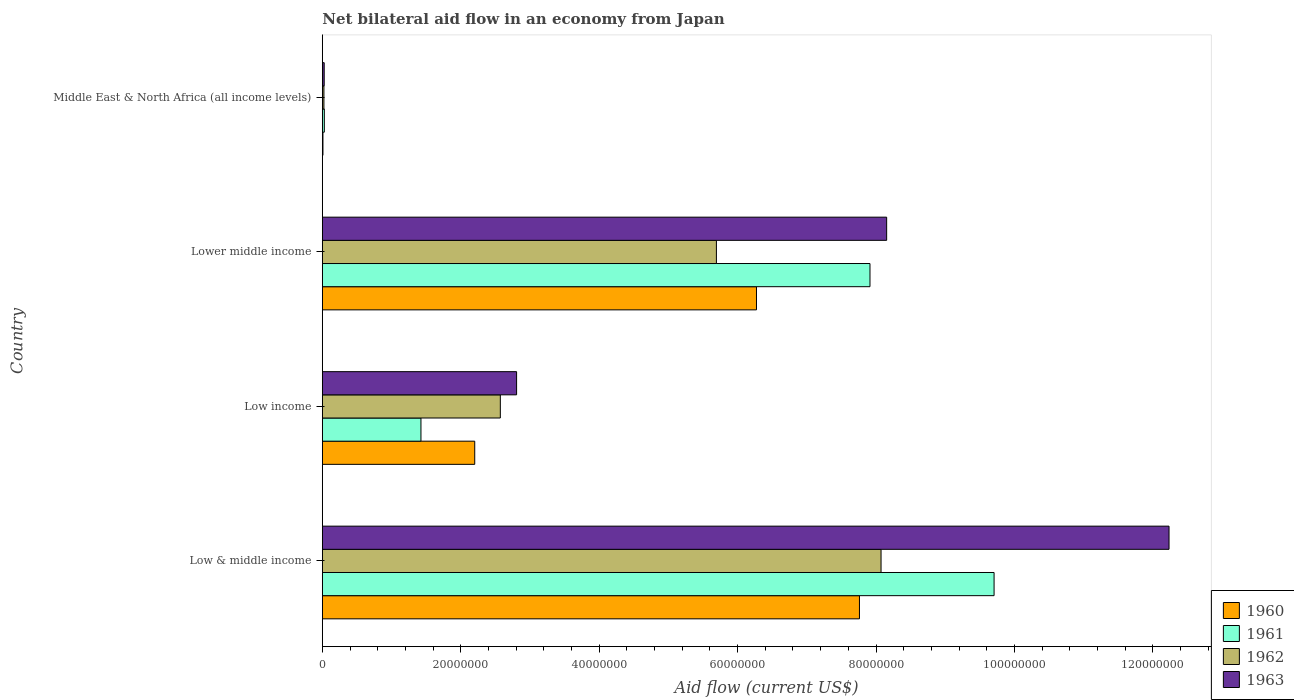How many groups of bars are there?
Provide a succinct answer. 4. Are the number of bars per tick equal to the number of legend labels?
Offer a very short reply. Yes. How many bars are there on the 1st tick from the bottom?
Give a very brief answer. 4. What is the label of the 4th group of bars from the top?
Make the answer very short. Low & middle income. In how many cases, is the number of bars for a given country not equal to the number of legend labels?
Offer a terse response. 0. What is the net bilateral aid flow in 1961 in Low & middle income?
Your answer should be very brief. 9.71e+07. Across all countries, what is the maximum net bilateral aid flow in 1961?
Your answer should be very brief. 9.71e+07. Across all countries, what is the minimum net bilateral aid flow in 1963?
Give a very brief answer. 2.70e+05. In which country was the net bilateral aid flow in 1962 maximum?
Offer a terse response. Low & middle income. In which country was the net bilateral aid flow in 1960 minimum?
Your answer should be compact. Middle East & North Africa (all income levels). What is the total net bilateral aid flow in 1961 in the graph?
Ensure brevity in your answer.  1.91e+08. What is the difference between the net bilateral aid flow in 1963 in Low income and that in Middle East & North Africa (all income levels)?
Offer a very short reply. 2.78e+07. What is the difference between the net bilateral aid flow in 1960 in Lower middle income and the net bilateral aid flow in 1963 in Low income?
Give a very brief answer. 3.47e+07. What is the average net bilateral aid flow in 1963 per country?
Keep it short and to the point. 5.81e+07. What is the difference between the net bilateral aid flow in 1963 and net bilateral aid flow in 1960 in Low income?
Offer a terse response. 6.05e+06. In how many countries, is the net bilateral aid flow in 1963 greater than 68000000 US$?
Provide a succinct answer. 2. What is the ratio of the net bilateral aid flow in 1963 in Low & middle income to that in Middle East & North Africa (all income levels)?
Give a very brief answer. 453.11. Is the net bilateral aid flow in 1963 in Low & middle income less than that in Low income?
Keep it short and to the point. No. Is the difference between the net bilateral aid flow in 1963 in Low & middle income and Middle East & North Africa (all income levels) greater than the difference between the net bilateral aid flow in 1960 in Low & middle income and Middle East & North Africa (all income levels)?
Offer a very short reply. Yes. What is the difference between the highest and the second highest net bilateral aid flow in 1962?
Your answer should be compact. 2.38e+07. What is the difference between the highest and the lowest net bilateral aid flow in 1962?
Offer a terse response. 8.05e+07. In how many countries, is the net bilateral aid flow in 1960 greater than the average net bilateral aid flow in 1960 taken over all countries?
Offer a terse response. 2. Is the sum of the net bilateral aid flow in 1960 in Low income and Lower middle income greater than the maximum net bilateral aid flow in 1962 across all countries?
Make the answer very short. Yes. What does the 3rd bar from the bottom in Low & middle income represents?
Offer a very short reply. 1962. Is it the case that in every country, the sum of the net bilateral aid flow in 1963 and net bilateral aid flow in 1960 is greater than the net bilateral aid flow in 1961?
Offer a terse response. Yes. Are all the bars in the graph horizontal?
Your answer should be very brief. Yes. How many countries are there in the graph?
Offer a very short reply. 4. Does the graph contain any zero values?
Keep it short and to the point. No. Does the graph contain grids?
Make the answer very short. No. Where does the legend appear in the graph?
Give a very brief answer. Bottom right. How many legend labels are there?
Your answer should be very brief. 4. How are the legend labels stacked?
Offer a terse response. Vertical. What is the title of the graph?
Your answer should be compact. Net bilateral aid flow in an economy from Japan. What is the label or title of the X-axis?
Make the answer very short. Aid flow (current US$). What is the label or title of the Y-axis?
Provide a short and direct response. Country. What is the Aid flow (current US$) in 1960 in Low & middle income?
Offer a very short reply. 7.76e+07. What is the Aid flow (current US$) of 1961 in Low & middle income?
Offer a terse response. 9.71e+07. What is the Aid flow (current US$) of 1962 in Low & middle income?
Provide a short and direct response. 8.07e+07. What is the Aid flow (current US$) of 1963 in Low & middle income?
Offer a very short reply. 1.22e+08. What is the Aid flow (current US$) in 1960 in Low income?
Provide a short and direct response. 2.20e+07. What is the Aid flow (current US$) in 1961 in Low income?
Give a very brief answer. 1.42e+07. What is the Aid flow (current US$) in 1962 in Low income?
Your answer should be compact. 2.57e+07. What is the Aid flow (current US$) in 1963 in Low income?
Ensure brevity in your answer.  2.81e+07. What is the Aid flow (current US$) of 1960 in Lower middle income?
Make the answer very short. 6.27e+07. What is the Aid flow (current US$) of 1961 in Lower middle income?
Your response must be concise. 7.91e+07. What is the Aid flow (current US$) in 1962 in Lower middle income?
Offer a terse response. 5.69e+07. What is the Aid flow (current US$) of 1963 in Lower middle income?
Provide a short and direct response. 8.15e+07. What is the Aid flow (current US$) in 1960 in Middle East & North Africa (all income levels)?
Offer a terse response. 9.00e+04. What is the Aid flow (current US$) in 1962 in Middle East & North Africa (all income levels)?
Your answer should be very brief. 2.30e+05. What is the Aid flow (current US$) of 1963 in Middle East & North Africa (all income levels)?
Provide a succinct answer. 2.70e+05. Across all countries, what is the maximum Aid flow (current US$) of 1960?
Offer a terse response. 7.76e+07. Across all countries, what is the maximum Aid flow (current US$) in 1961?
Your answer should be very brief. 9.71e+07. Across all countries, what is the maximum Aid flow (current US$) of 1962?
Give a very brief answer. 8.07e+07. Across all countries, what is the maximum Aid flow (current US$) in 1963?
Give a very brief answer. 1.22e+08. Across all countries, what is the minimum Aid flow (current US$) of 1961?
Keep it short and to the point. 2.90e+05. Across all countries, what is the minimum Aid flow (current US$) in 1963?
Your answer should be compact. 2.70e+05. What is the total Aid flow (current US$) of 1960 in the graph?
Offer a terse response. 1.62e+08. What is the total Aid flow (current US$) of 1961 in the graph?
Give a very brief answer. 1.91e+08. What is the total Aid flow (current US$) in 1962 in the graph?
Keep it short and to the point. 1.64e+08. What is the total Aid flow (current US$) of 1963 in the graph?
Ensure brevity in your answer.  2.32e+08. What is the difference between the Aid flow (current US$) in 1960 in Low & middle income and that in Low income?
Your answer should be very brief. 5.56e+07. What is the difference between the Aid flow (current US$) in 1961 in Low & middle income and that in Low income?
Provide a short and direct response. 8.28e+07. What is the difference between the Aid flow (current US$) of 1962 in Low & middle income and that in Low income?
Provide a succinct answer. 5.50e+07. What is the difference between the Aid flow (current US$) of 1963 in Low & middle income and that in Low income?
Offer a very short reply. 9.43e+07. What is the difference between the Aid flow (current US$) in 1960 in Low & middle income and that in Lower middle income?
Your answer should be very brief. 1.49e+07. What is the difference between the Aid flow (current US$) in 1961 in Low & middle income and that in Lower middle income?
Provide a succinct answer. 1.79e+07. What is the difference between the Aid flow (current US$) of 1962 in Low & middle income and that in Lower middle income?
Offer a terse response. 2.38e+07. What is the difference between the Aid flow (current US$) of 1963 in Low & middle income and that in Lower middle income?
Offer a very short reply. 4.08e+07. What is the difference between the Aid flow (current US$) of 1960 in Low & middle income and that in Middle East & North Africa (all income levels)?
Your response must be concise. 7.75e+07. What is the difference between the Aid flow (current US$) of 1961 in Low & middle income and that in Middle East & North Africa (all income levels)?
Your answer should be compact. 9.68e+07. What is the difference between the Aid flow (current US$) of 1962 in Low & middle income and that in Middle East & North Africa (all income levels)?
Give a very brief answer. 8.05e+07. What is the difference between the Aid flow (current US$) of 1963 in Low & middle income and that in Middle East & North Africa (all income levels)?
Offer a very short reply. 1.22e+08. What is the difference between the Aid flow (current US$) in 1960 in Low income and that in Lower middle income?
Your answer should be compact. -4.07e+07. What is the difference between the Aid flow (current US$) of 1961 in Low income and that in Lower middle income?
Your answer should be compact. -6.49e+07. What is the difference between the Aid flow (current US$) in 1962 in Low income and that in Lower middle income?
Offer a terse response. -3.12e+07. What is the difference between the Aid flow (current US$) of 1963 in Low income and that in Lower middle income?
Keep it short and to the point. -5.35e+07. What is the difference between the Aid flow (current US$) in 1960 in Low income and that in Middle East & North Africa (all income levels)?
Offer a very short reply. 2.19e+07. What is the difference between the Aid flow (current US$) in 1961 in Low income and that in Middle East & North Africa (all income levels)?
Offer a very short reply. 1.40e+07. What is the difference between the Aid flow (current US$) in 1962 in Low income and that in Middle East & North Africa (all income levels)?
Give a very brief answer. 2.55e+07. What is the difference between the Aid flow (current US$) in 1963 in Low income and that in Middle East & North Africa (all income levels)?
Make the answer very short. 2.78e+07. What is the difference between the Aid flow (current US$) of 1960 in Lower middle income and that in Middle East & North Africa (all income levels)?
Ensure brevity in your answer.  6.26e+07. What is the difference between the Aid flow (current US$) of 1961 in Lower middle income and that in Middle East & North Africa (all income levels)?
Offer a terse response. 7.88e+07. What is the difference between the Aid flow (current US$) of 1962 in Lower middle income and that in Middle East & North Africa (all income levels)?
Provide a short and direct response. 5.67e+07. What is the difference between the Aid flow (current US$) in 1963 in Lower middle income and that in Middle East & North Africa (all income levels)?
Your response must be concise. 8.13e+07. What is the difference between the Aid flow (current US$) in 1960 in Low & middle income and the Aid flow (current US$) in 1961 in Low income?
Offer a very short reply. 6.34e+07. What is the difference between the Aid flow (current US$) in 1960 in Low & middle income and the Aid flow (current US$) in 1962 in Low income?
Keep it short and to the point. 5.19e+07. What is the difference between the Aid flow (current US$) of 1960 in Low & middle income and the Aid flow (current US$) of 1963 in Low income?
Provide a succinct answer. 4.95e+07. What is the difference between the Aid flow (current US$) in 1961 in Low & middle income and the Aid flow (current US$) in 1962 in Low income?
Give a very brief answer. 7.13e+07. What is the difference between the Aid flow (current US$) of 1961 in Low & middle income and the Aid flow (current US$) of 1963 in Low income?
Give a very brief answer. 6.90e+07. What is the difference between the Aid flow (current US$) of 1962 in Low & middle income and the Aid flow (current US$) of 1963 in Low income?
Keep it short and to the point. 5.27e+07. What is the difference between the Aid flow (current US$) in 1960 in Low & middle income and the Aid flow (current US$) in 1961 in Lower middle income?
Your answer should be very brief. -1.52e+06. What is the difference between the Aid flow (current US$) of 1960 in Low & middle income and the Aid flow (current US$) of 1962 in Lower middle income?
Your answer should be very brief. 2.07e+07. What is the difference between the Aid flow (current US$) in 1960 in Low & middle income and the Aid flow (current US$) in 1963 in Lower middle income?
Your response must be concise. -3.93e+06. What is the difference between the Aid flow (current US$) of 1961 in Low & middle income and the Aid flow (current US$) of 1962 in Lower middle income?
Offer a very short reply. 4.01e+07. What is the difference between the Aid flow (current US$) of 1961 in Low & middle income and the Aid flow (current US$) of 1963 in Lower middle income?
Provide a succinct answer. 1.55e+07. What is the difference between the Aid flow (current US$) in 1962 in Low & middle income and the Aid flow (current US$) in 1963 in Lower middle income?
Offer a very short reply. -8.10e+05. What is the difference between the Aid flow (current US$) in 1960 in Low & middle income and the Aid flow (current US$) in 1961 in Middle East & North Africa (all income levels)?
Keep it short and to the point. 7.73e+07. What is the difference between the Aid flow (current US$) in 1960 in Low & middle income and the Aid flow (current US$) in 1962 in Middle East & North Africa (all income levels)?
Give a very brief answer. 7.74e+07. What is the difference between the Aid flow (current US$) of 1960 in Low & middle income and the Aid flow (current US$) of 1963 in Middle East & North Africa (all income levels)?
Your response must be concise. 7.73e+07. What is the difference between the Aid flow (current US$) in 1961 in Low & middle income and the Aid flow (current US$) in 1962 in Middle East & North Africa (all income levels)?
Make the answer very short. 9.68e+07. What is the difference between the Aid flow (current US$) in 1961 in Low & middle income and the Aid flow (current US$) in 1963 in Middle East & North Africa (all income levels)?
Your answer should be compact. 9.68e+07. What is the difference between the Aid flow (current US$) of 1962 in Low & middle income and the Aid flow (current US$) of 1963 in Middle East & North Africa (all income levels)?
Provide a succinct answer. 8.05e+07. What is the difference between the Aid flow (current US$) in 1960 in Low income and the Aid flow (current US$) in 1961 in Lower middle income?
Your response must be concise. -5.71e+07. What is the difference between the Aid flow (current US$) of 1960 in Low income and the Aid flow (current US$) of 1962 in Lower middle income?
Your response must be concise. -3.49e+07. What is the difference between the Aid flow (current US$) of 1960 in Low income and the Aid flow (current US$) of 1963 in Lower middle income?
Provide a short and direct response. -5.95e+07. What is the difference between the Aid flow (current US$) of 1961 in Low income and the Aid flow (current US$) of 1962 in Lower middle income?
Your response must be concise. -4.27e+07. What is the difference between the Aid flow (current US$) of 1961 in Low income and the Aid flow (current US$) of 1963 in Lower middle income?
Your answer should be very brief. -6.73e+07. What is the difference between the Aid flow (current US$) in 1962 in Low income and the Aid flow (current US$) in 1963 in Lower middle income?
Give a very brief answer. -5.58e+07. What is the difference between the Aid flow (current US$) in 1960 in Low income and the Aid flow (current US$) in 1961 in Middle East & North Africa (all income levels)?
Give a very brief answer. 2.17e+07. What is the difference between the Aid flow (current US$) of 1960 in Low income and the Aid flow (current US$) of 1962 in Middle East & North Africa (all income levels)?
Ensure brevity in your answer.  2.18e+07. What is the difference between the Aid flow (current US$) in 1960 in Low income and the Aid flow (current US$) in 1963 in Middle East & North Africa (all income levels)?
Keep it short and to the point. 2.18e+07. What is the difference between the Aid flow (current US$) of 1961 in Low income and the Aid flow (current US$) of 1962 in Middle East & North Africa (all income levels)?
Keep it short and to the point. 1.40e+07. What is the difference between the Aid flow (current US$) of 1961 in Low income and the Aid flow (current US$) of 1963 in Middle East & North Africa (all income levels)?
Your response must be concise. 1.40e+07. What is the difference between the Aid flow (current US$) in 1962 in Low income and the Aid flow (current US$) in 1963 in Middle East & North Africa (all income levels)?
Provide a succinct answer. 2.54e+07. What is the difference between the Aid flow (current US$) in 1960 in Lower middle income and the Aid flow (current US$) in 1961 in Middle East & North Africa (all income levels)?
Your response must be concise. 6.24e+07. What is the difference between the Aid flow (current US$) in 1960 in Lower middle income and the Aid flow (current US$) in 1962 in Middle East & North Africa (all income levels)?
Your response must be concise. 6.25e+07. What is the difference between the Aid flow (current US$) in 1960 in Lower middle income and the Aid flow (current US$) in 1963 in Middle East & North Africa (all income levels)?
Give a very brief answer. 6.25e+07. What is the difference between the Aid flow (current US$) of 1961 in Lower middle income and the Aid flow (current US$) of 1962 in Middle East & North Africa (all income levels)?
Offer a very short reply. 7.89e+07. What is the difference between the Aid flow (current US$) in 1961 in Lower middle income and the Aid flow (current US$) in 1963 in Middle East & North Africa (all income levels)?
Offer a very short reply. 7.89e+07. What is the difference between the Aid flow (current US$) in 1962 in Lower middle income and the Aid flow (current US$) in 1963 in Middle East & North Africa (all income levels)?
Ensure brevity in your answer.  5.67e+07. What is the average Aid flow (current US$) of 1960 per country?
Give a very brief answer. 4.06e+07. What is the average Aid flow (current US$) of 1961 per country?
Offer a very short reply. 4.77e+07. What is the average Aid flow (current US$) in 1962 per country?
Your answer should be very brief. 4.09e+07. What is the average Aid flow (current US$) of 1963 per country?
Offer a very short reply. 5.81e+07. What is the difference between the Aid flow (current US$) of 1960 and Aid flow (current US$) of 1961 in Low & middle income?
Your answer should be compact. -1.94e+07. What is the difference between the Aid flow (current US$) in 1960 and Aid flow (current US$) in 1962 in Low & middle income?
Keep it short and to the point. -3.12e+06. What is the difference between the Aid flow (current US$) in 1960 and Aid flow (current US$) in 1963 in Low & middle income?
Your answer should be very brief. -4.47e+07. What is the difference between the Aid flow (current US$) of 1961 and Aid flow (current US$) of 1962 in Low & middle income?
Your answer should be compact. 1.63e+07. What is the difference between the Aid flow (current US$) of 1961 and Aid flow (current US$) of 1963 in Low & middle income?
Offer a very short reply. -2.53e+07. What is the difference between the Aid flow (current US$) of 1962 and Aid flow (current US$) of 1963 in Low & middle income?
Make the answer very short. -4.16e+07. What is the difference between the Aid flow (current US$) in 1960 and Aid flow (current US$) in 1961 in Low income?
Offer a terse response. 7.77e+06. What is the difference between the Aid flow (current US$) in 1960 and Aid flow (current US$) in 1962 in Low income?
Give a very brief answer. -3.70e+06. What is the difference between the Aid flow (current US$) of 1960 and Aid flow (current US$) of 1963 in Low income?
Your answer should be compact. -6.05e+06. What is the difference between the Aid flow (current US$) of 1961 and Aid flow (current US$) of 1962 in Low income?
Provide a short and direct response. -1.15e+07. What is the difference between the Aid flow (current US$) of 1961 and Aid flow (current US$) of 1963 in Low income?
Ensure brevity in your answer.  -1.38e+07. What is the difference between the Aid flow (current US$) of 1962 and Aid flow (current US$) of 1963 in Low income?
Ensure brevity in your answer.  -2.35e+06. What is the difference between the Aid flow (current US$) in 1960 and Aid flow (current US$) in 1961 in Lower middle income?
Offer a very short reply. -1.64e+07. What is the difference between the Aid flow (current US$) in 1960 and Aid flow (current US$) in 1962 in Lower middle income?
Offer a very short reply. 5.79e+06. What is the difference between the Aid flow (current US$) in 1960 and Aid flow (current US$) in 1963 in Lower middle income?
Give a very brief answer. -1.88e+07. What is the difference between the Aid flow (current US$) in 1961 and Aid flow (current US$) in 1962 in Lower middle income?
Keep it short and to the point. 2.22e+07. What is the difference between the Aid flow (current US$) in 1961 and Aid flow (current US$) in 1963 in Lower middle income?
Ensure brevity in your answer.  -2.41e+06. What is the difference between the Aid flow (current US$) in 1962 and Aid flow (current US$) in 1963 in Lower middle income?
Provide a short and direct response. -2.46e+07. What is the difference between the Aid flow (current US$) of 1960 and Aid flow (current US$) of 1961 in Middle East & North Africa (all income levels)?
Keep it short and to the point. -2.00e+05. What is the difference between the Aid flow (current US$) in 1961 and Aid flow (current US$) in 1962 in Middle East & North Africa (all income levels)?
Your response must be concise. 6.00e+04. What is the ratio of the Aid flow (current US$) of 1960 in Low & middle income to that in Low income?
Make the answer very short. 3.52. What is the ratio of the Aid flow (current US$) of 1961 in Low & middle income to that in Low income?
Make the answer very short. 6.81. What is the ratio of the Aid flow (current US$) of 1962 in Low & middle income to that in Low income?
Your answer should be very brief. 3.14. What is the ratio of the Aid flow (current US$) of 1963 in Low & middle income to that in Low income?
Your answer should be compact. 4.36. What is the ratio of the Aid flow (current US$) in 1960 in Low & middle income to that in Lower middle income?
Give a very brief answer. 1.24. What is the ratio of the Aid flow (current US$) of 1961 in Low & middle income to that in Lower middle income?
Your answer should be very brief. 1.23. What is the ratio of the Aid flow (current US$) of 1962 in Low & middle income to that in Lower middle income?
Offer a very short reply. 1.42. What is the ratio of the Aid flow (current US$) of 1963 in Low & middle income to that in Lower middle income?
Your answer should be compact. 1.5. What is the ratio of the Aid flow (current US$) in 1960 in Low & middle income to that in Middle East & North Africa (all income levels)?
Provide a short and direct response. 862.33. What is the ratio of the Aid flow (current US$) of 1961 in Low & middle income to that in Middle East & North Africa (all income levels)?
Offer a very short reply. 334.69. What is the ratio of the Aid flow (current US$) of 1962 in Low & middle income to that in Middle East & North Africa (all income levels)?
Keep it short and to the point. 351. What is the ratio of the Aid flow (current US$) of 1963 in Low & middle income to that in Middle East & North Africa (all income levels)?
Your answer should be very brief. 453.11. What is the ratio of the Aid flow (current US$) of 1960 in Low income to that in Lower middle income?
Make the answer very short. 0.35. What is the ratio of the Aid flow (current US$) of 1961 in Low income to that in Lower middle income?
Keep it short and to the point. 0.18. What is the ratio of the Aid flow (current US$) in 1962 in Low income to that in Lower middle income?
Your response must be concise. 0.45. What is the ratio of the Aid flow (current US$) of 1963 in Low income to that in Lower middle income?
Provide a short and direct response. 0.34. What is the ratio of the Aid flow (current US$) in 1960 in Low income to that in Middle East & North Africa (all income levels)?
Your response must be concise. 244.67. What is the ratio of the Aid flow (current US$) in 1961 in Low income to that in Middle East & North Africa (all income levels)?
Offer a very short reply. 49.14. What is the ratio of the Aid flow (current US$) of 1962 in Low income to that in Middle East & North Africa (all income levels)?
Your answer should be compact. 111.83. What is the ratio of the Aid flow (current US$) of 1963 in Low income to that in Middle East & North Africa (all income levels)?
Your response must be concise. 103.96. What is the ratio of the Aid flow (current US$) of 1960 in Lower middle income to that in Middle East & North Africa (all income levels)?
Your answer should be very brief. 697. What is the ratio of the Aid flow (current US$) in 1961 in Lower middle income to that in Middle East & North Africa (all income levels)?
Ensure brevity in your answer.  272.86. What is the ratio of the Aid flow (current US$) in 1962 in Lower middle income to that in Middle East & North Africa (all income levels)?
Your answer should be very brief. 247.57. What is the ratio of the Aid flow (current US$) of 1963 in Lower middle income to that in Middle East & North Africa (all income levels)?
Offer a very short reply. 302. What is the difference between the highest and the second highest Aid flow (current US$) in 1960?
Offer a very short reply. 1.49e+07. What is the difference between the highest and the second highest Aid flow (current US$) in 1961?
Provide a short and direct response. 1.79e+07. What is the difference between the highest and the second highest Aid flow (current US$) of 1962?
Ensure brevity in your answer.  2.38e+07. What is the difference between the highest and the second highest Aid flow (current US$) of 1963?
Provide a short and direct response. 4.08e+07. What is the difference between the highest and the lowest Aid flow (current US$) in 1960?
Your response must be concise. 7.75e+07. What is the difference between the highest and the lowest Aid flow (current US$) in 1961?
Your answer should be compact. 9.68e+07. What is the difference between the highest and the lowest Aid flow (current US$) of 1962?
Make the answer very short. 8.05e+07. What is the difference between the highest and the lowest Aid flow (current US$) of 1963?
Your response must be concise. 1.22e+08. 